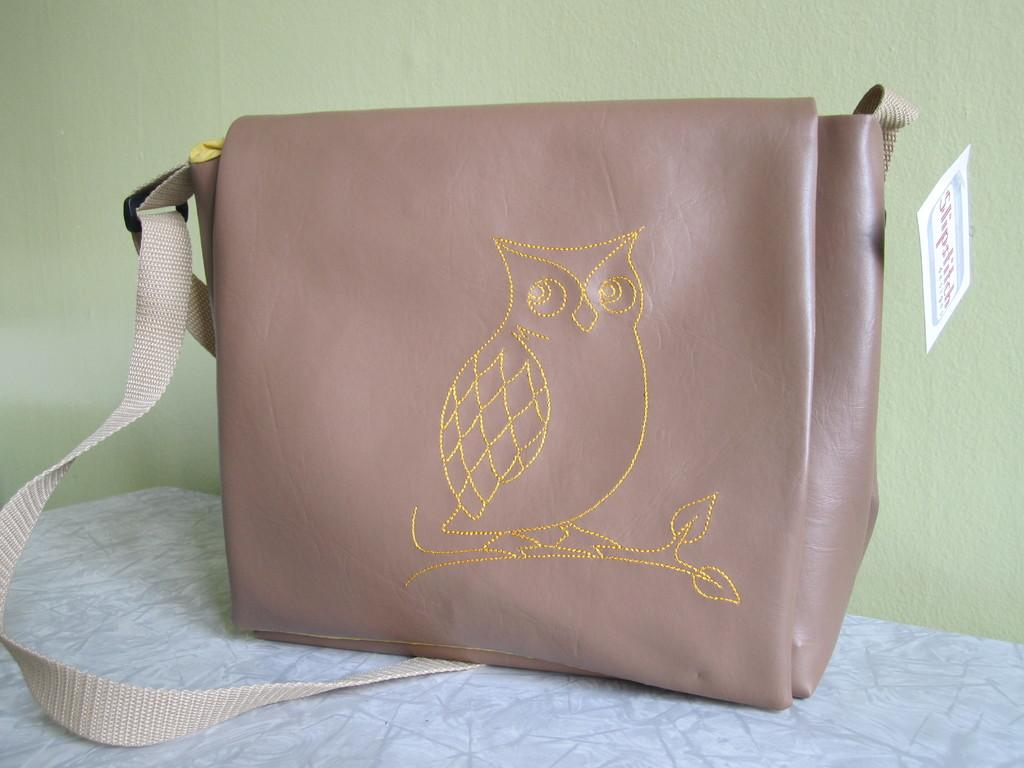What object is featured in the picture? There is a handbag in the picture. What design element is present on the handbag? The handbag has an owl figure on it. What color is the handbag? The handbag is cream-colored. What can be seen in the background of the picture? There is a wall in the background of the picture. Where is the handbag located in the image? The handbag is placed on a table. What type of metal is used in the construction of the handbag? The handbag is not made of metal; it is made of a material that resembles leather or fabric. What industry is depicted in the image? There is no industry depicted in the image; it features a handbag with an owl design. 